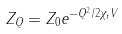<formula> <loc_0><loc_0><loc_500><loc_500>Z _ { Q } = Z _ { 0 } e ^ { - Q ^ { 2 } / 2 \chi _ { t } V }</formula> 